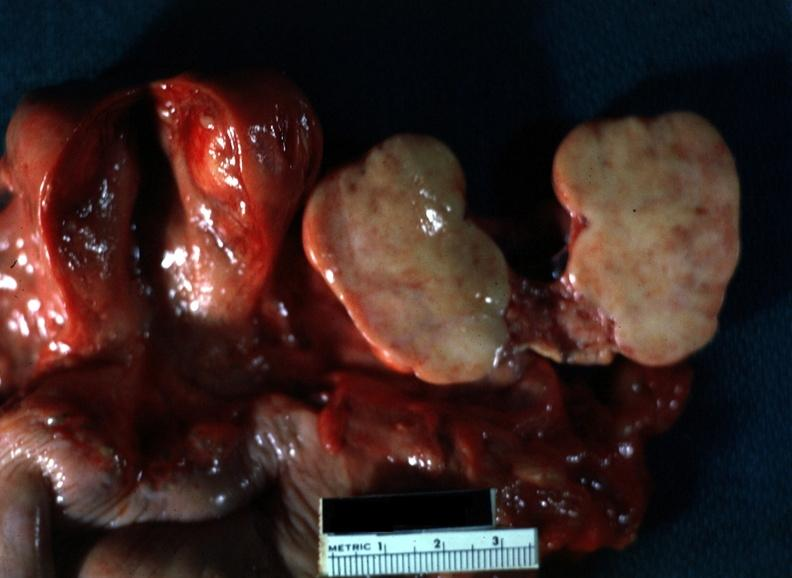what sliced open like a book typical for this lesion with yellow foci evident view of all pelvic organ in slide?
Answer the question using a single word or phrase. Close-up 